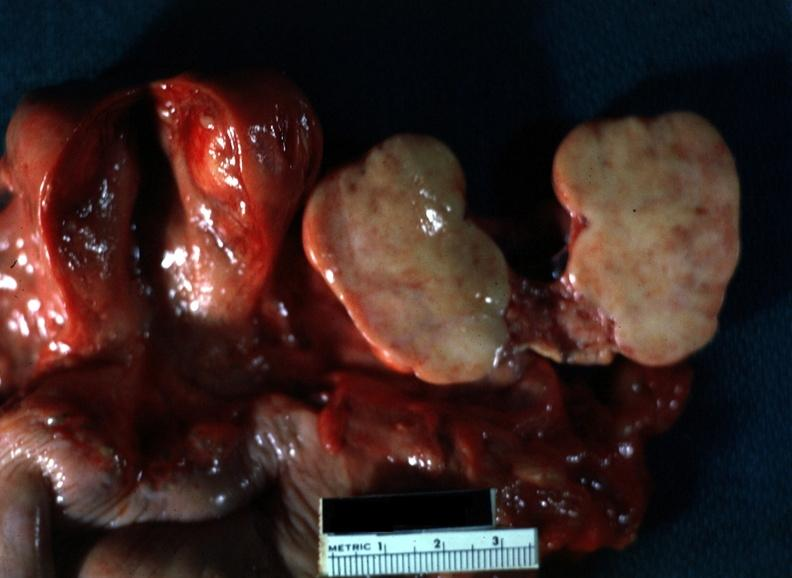what sliced open like a book typical for this lesion with yellow foci evident view of all pelvic organ in slide?
Answer the question using a single word or phrase. Close-up 